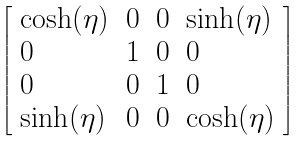<formula> <loc_0><loc_0><loc_500><loc_500>\left [ \begin{array} { l l l l } { \cosh ( \eta ) } & { 0 } & { 0 } & { \sinh ( \eta ) } \\ { 0 } & { 1 } & { 0 } & { 0 } \\ { 0 } & { 0 } & { 1 } & { 0 } \\ { \sinh ( \eta ) } & { 0 } & { 0 } & { \cosh ( \eta ) } \end{array} \right ]</formula> 